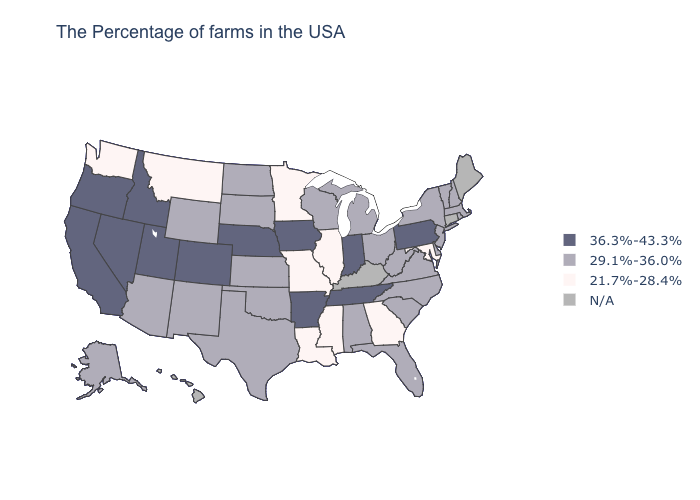What is the lowest value in the Northeast?
Concise answer only. 29.1%-36.0%. What is the value of North Carolina?
Be succinct. 29.1%-36.0%. Name the states that have a value in the range N/A?
Be succinct. Maine, Connecticut, Kentucky, Hawaii. Which states have the lowest value in the USA?
Concise answer only. Maryland, Georgia, Illinois, Mississippi, Louisiana, Missouri, Minnesota, Montana, Washington. Among the states that border Georgia , which have the highest value?
Quick response, please. Tennessee. What is the value of Iowa?
Be succinct. 36.3%-43.3%. Does the first symbol in the legend represent the smallest category?
Answer briefly. No. Name the states that have a value in the range 29.1%-36.0%?
Give a very brief answer. Massachusetts, Rhode Island, New Hampshire, Vermont, New York, New Jersey, Delaware, Virginia, North Carolina, South Carolina, West Virginia, Ohio, Florida, Michigan, Alabama, Wisconsin, Kansas, Oklahoma, Texas, South Dakota, North Dakota, Wyoming, New Mexico, Arizona, Alaska. Name the states that have a value in the range 36.3%-43.3%?
Write a very short answer. Pennsylvania, Indiana, Tennessee, Arkansas, Iowa, Nebraska, Colorado, Utah, Idaho, Nevada, California, Oregon. Which states have the highest value in the USA?
Concise answer only. Pennsylvania, Indiana, Tennessee, Arkansas, Iowa, Nebraska, Colorado, Utah, Idaho, Nevada, California, Oregon. Does the map have missing data?
Give a very brief answer. Yes. What is the highest value in the USA?
Keep it brief. 36.3%-43.3%. Does Washington have the lowest value in the USA?
Keep it brief. Yes. Is the legend a continuous bar?
Be succinct. No. 